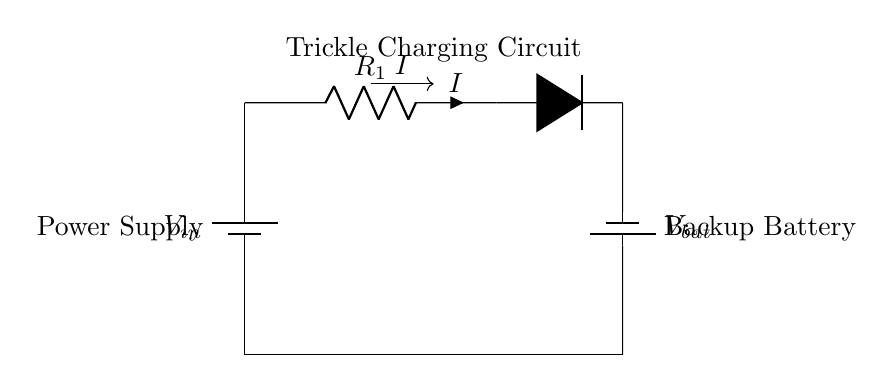What is the main purpose of this circuit? The main purpose is to provide a trickle charge to the backup battery, ensuring it remains charged for use in the guitar amplifier.
Answer: Trickle charge What is the role of the diode in this circuit? The diode allows current to flow only in one direction, preventing backflow from the battery that could damage the power supply.
Answer: Prevents backflow What component limits the charging current in this circuit? The resistor, labeled R1, limits the amount of current flowing into the battery, controlling the charging rate to prevent overcharging.
Answer: Resistor What type of battery is shown in the diagram? The diagram illustrates a backup battery, indicated by the battery symbol and labeled as Vbat, which stores energy for the amplifier.
Answer: Backup battery How does the charging current flow in this circuit? The charging current flows from the power supply through the resistor, into the diode, and then charges the backup battery, as indicated by the current direction arrow.
Answer: From power supply to battery What happens if the battery is fully charged? If the battery is fully charged, the current will stop flowing into the battery due to the blocking effect of the diode, preventing overcharging, assuming no load is present.
Answer: Current stops flowing What would occur if the diode were removed from this circuit? Without the diode, the current could flow back from the battery to the power supply when the supply voltage drops, which may damage the power supply and affect the circuit's functionality.
Answer: Potential damage to power supply 